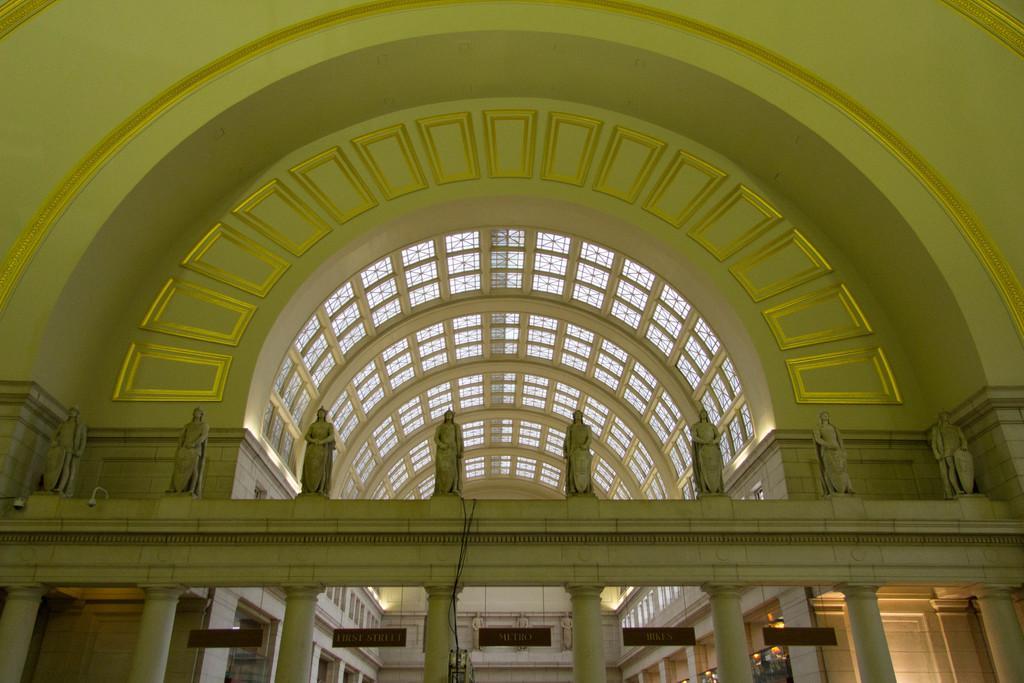Describe this image in one or two sentences. In this image there are sculptures on the concrete surface supported by pillars, behind the sculptures there is a glass rooftop supported by metal rods. On the walls there are some designs and there are some objects hanging. 